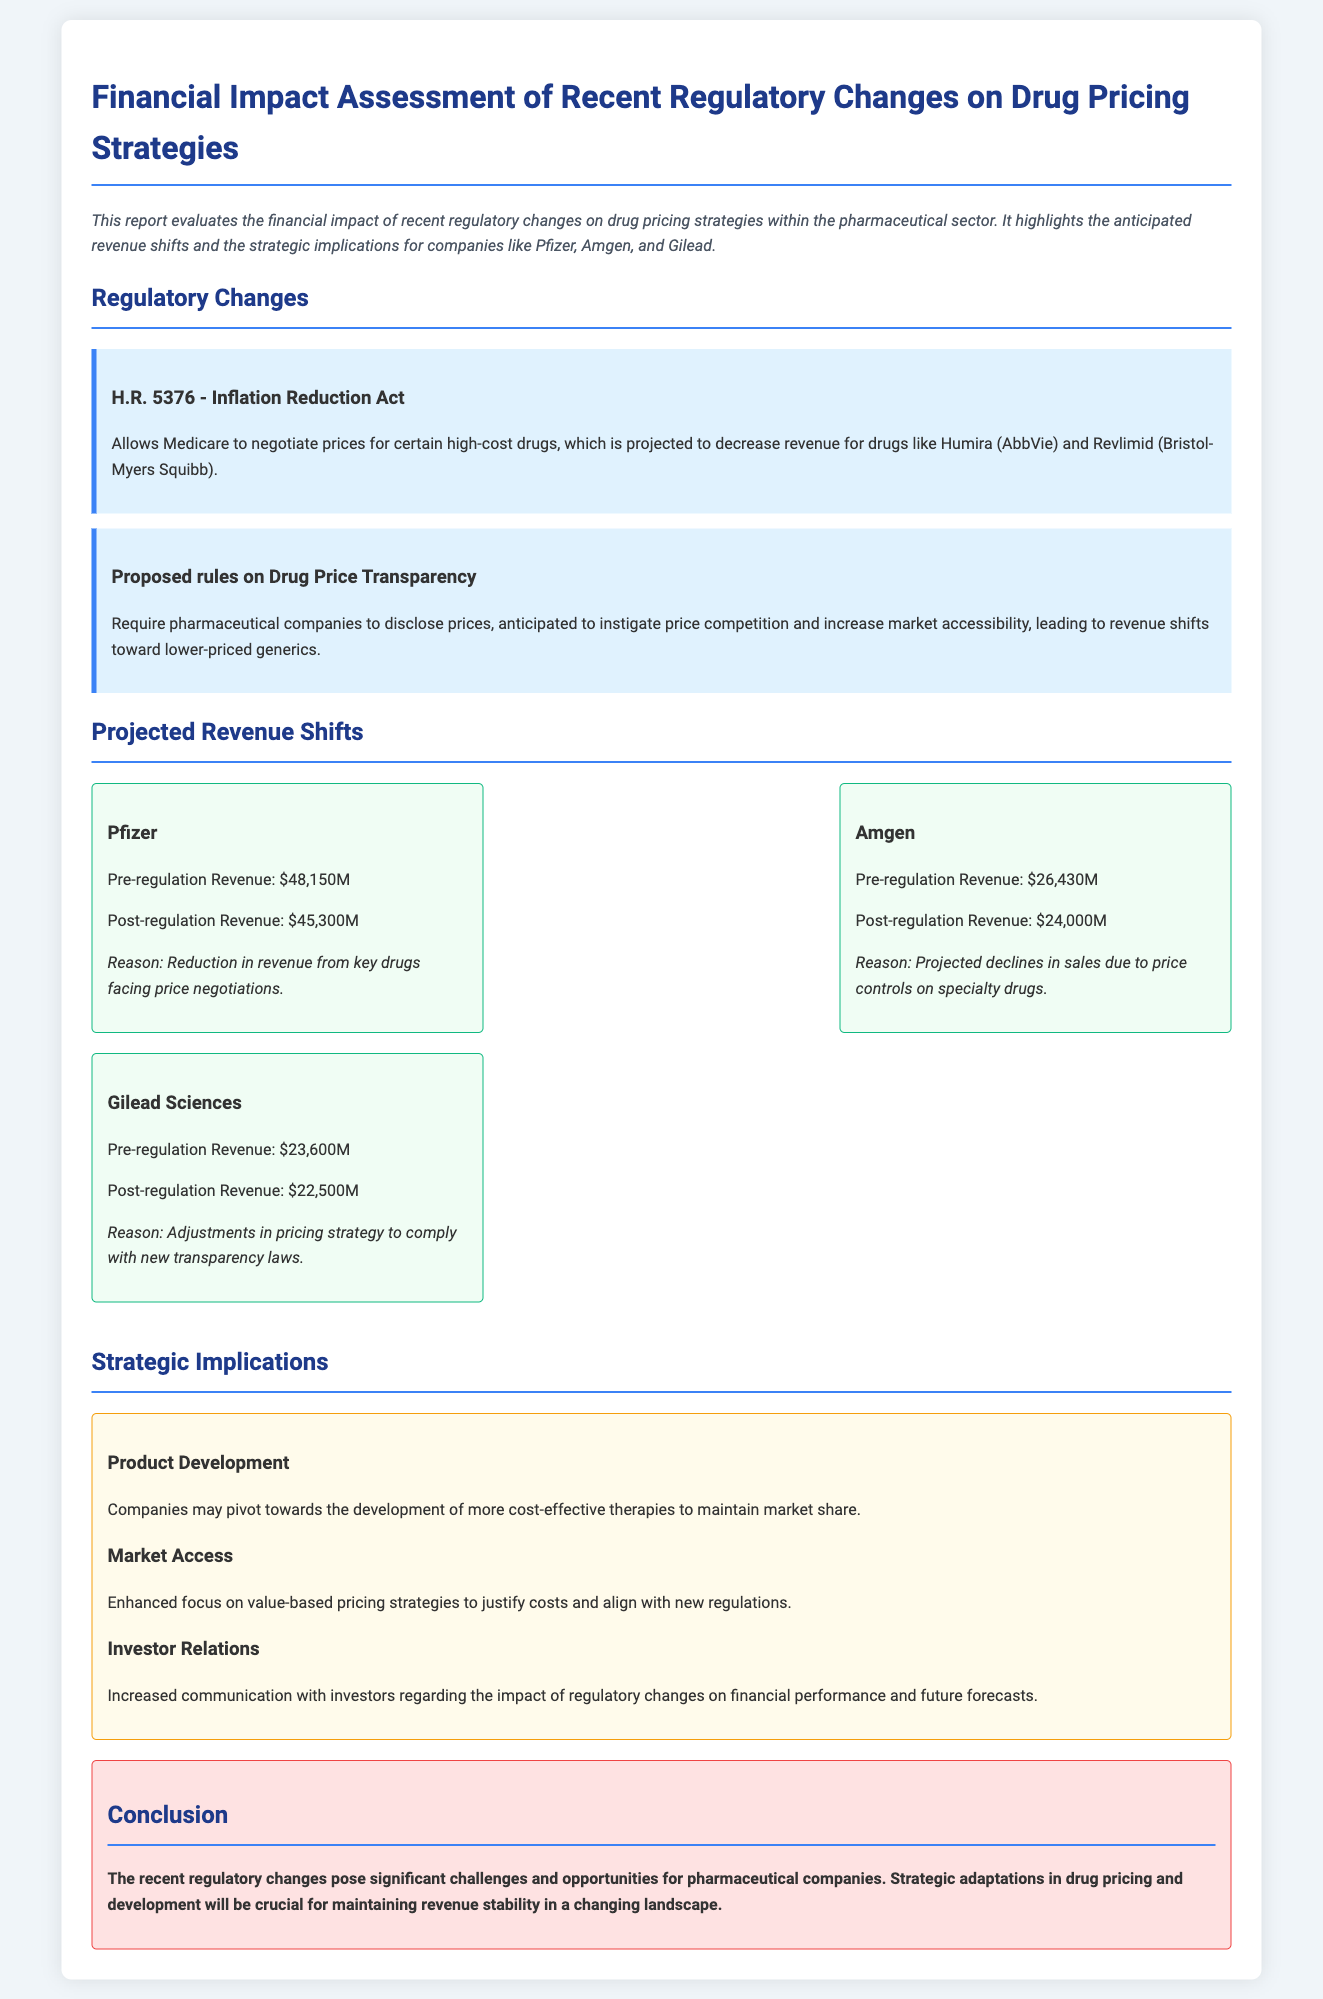What is the title of the report? The title is stated at the beginning of the document and provides a summary of the report's focus on financial impacts due to regulatory changes.
Answer: Financial Impact Assessment of Recent Regulatory Changes on Drug Pricing Strategies What is the main reason for revenue decline at Pfizer? The report highlights that the decline in revenue for Pfizer is primarily due to price negotiations affecting key drugs.
Answer: Reduction in revenue from key drugs facing price negotiations What was Amgen's pre-regulation revenue? The pre-regulation revenue for Amgen is indicated in the company's revenue section of the document.
Answer: $26,430M What regulatory change allows Medicare to negotiate prices? The specific regulatory change that enables Medicare to negotiate on drug prices is clearly identified in the document's regulation section.
Answer: H.R. 5376 - Inflation Reduction Act What strategic focus is suggested for companies in response to new regulations? The document outlines a shift towards developing cost-effective therapies as a recommended strategic adaptation for companies.
Answer: Product Development What is Gilead Sciences' projected post-regulation revenue? The report contains a specific projected revenue for Gilead Sciences after the regulatory changes.
Answer: $22,500M What type of pricing strategies are companies encouraged to adopt? The report discusses a push towards value-based pricing strategies, which is mentioned in the strategic implications section.
Answer: Value-based pricing strategies How does the report conclude regarding the challenges faced by pharmaceutical companies? The conclusion summarizes the overall impact of regulatory changes, focusing on challenges and opportunities in the sector.
Answer: Significant challenges and opportunities for pharmaceutical companies 